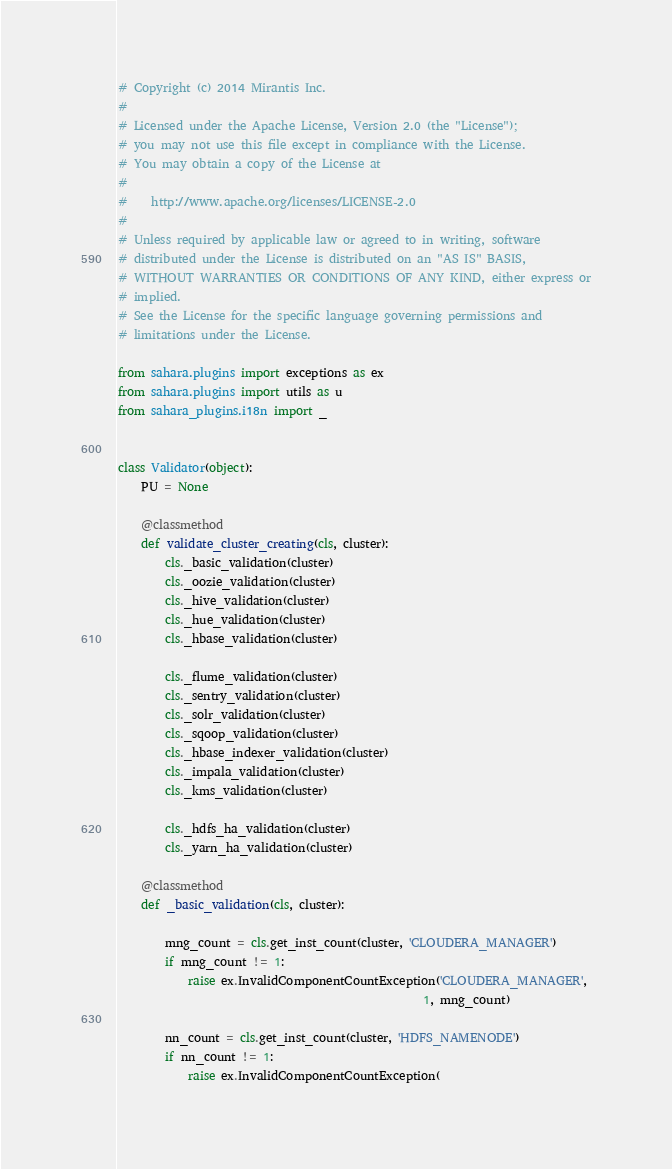<code> <loc_0><loc_0><loc_500><loc_500><_Python_># Copyright (c) 2014 Mirantis Inc.
#
# Licensed under the Apache License, Version 2.0 (the "License");
# you may not use this file except in compliance with the License.
# You may obtain a copy of the License at
#
#    http://www.apache.org/licenses/LICENSE-2.0
#
# Unless required by applicable law or agreed to in writing, software
# distributed under the License is distributed on an "AS IS" BASIS,
# WITHOUT WARRANTIES OR CONDITIONS OF ANY KIND, either express or
# implied.
# See the License for the specific language governing permissions and
# limitations under the License.

from sahara.plugins import exceptions as ex
from sahara.plugins import utils as u
from sahara_plugins.i18n import _


class Validator(object):
    PU = None

    @classmethod
    def validate_cluster_creating(cls, cluster):
        cls._basic_validation(cluster)
        cls._oozie_validation(cluster)
        cls._hive_validation(cluster)
        cls._hue_validation(cluster)
        cls._hbase_validation(cluster)

        cls._flume_validation(cluster)
        cls._sentry_validation(cluster)
        cls._solr_validation(cluster)
        cls._sqoop_validation(cluster)
        cls._hbase_indexer_validation(cluster)
        cls._impala_validation(cluster)
        cls._kms_validation(cluster)

        cls._hdfs_ha_validation(cluster)
        cls._yarn_ha_validation(cluster)

    @classmethod
    def _basic_validation(cls, cluster):

        mng_count = cls.get_inst_count(cluster, 'CLOUDERA_MANAGER')
        if mng_count != 1:
            raise ex.InvalidComponentCountException('CLOUDERA_MANAGER',
                                                    1, mng_count)

        nn_count = cls.get_inst_count(cluster, 'HDFS_NAMENODE')
        if nn_count != 1:
            raise ex.InvalidComponentCountException(</code> 